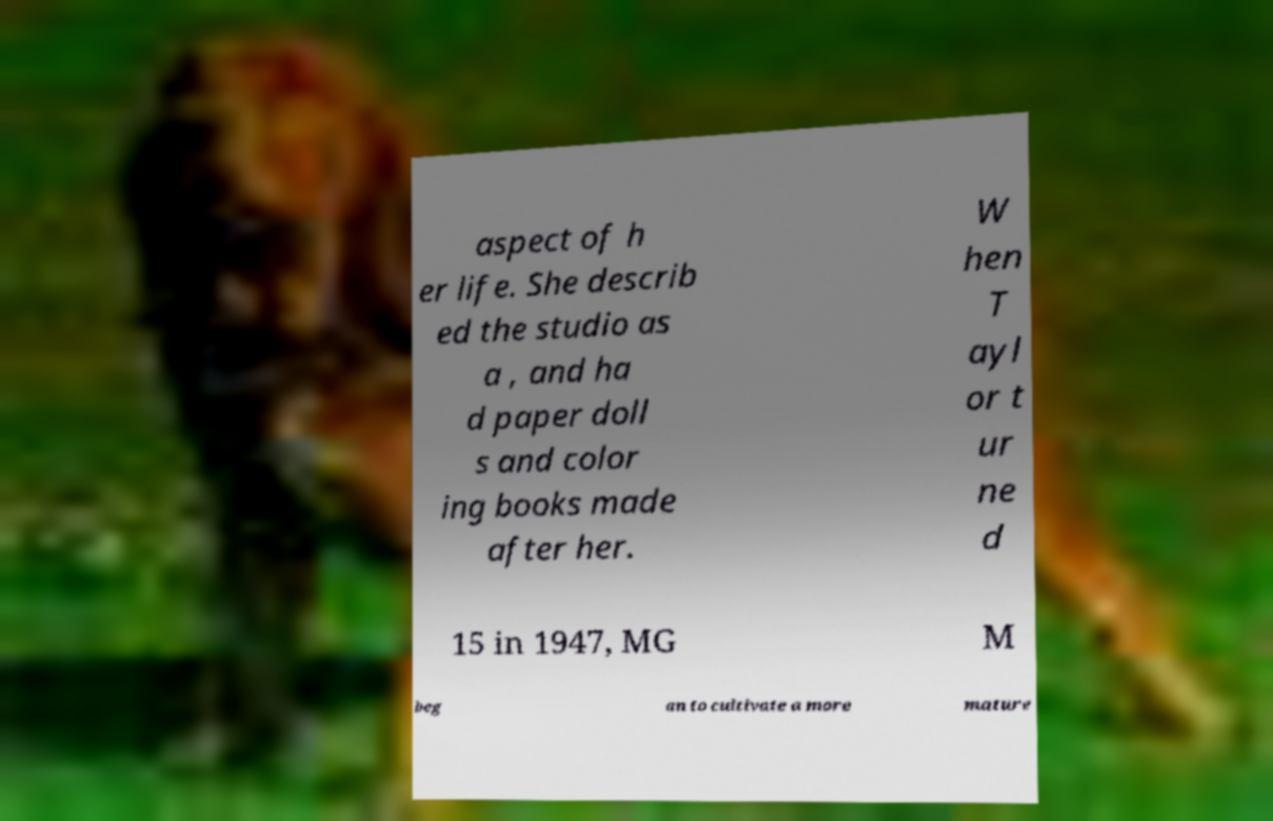Can you read and provide the text displayed in the image?This photo seems to have some interesting text. Can you extract and type it out for me? aspect of h er life. She describ ed the studio as a , and ha d paper doll s and color ing books made after her. W hen T ayl or t ur ne d 15 in 1947, MG M beg an to cultivate a more mature 